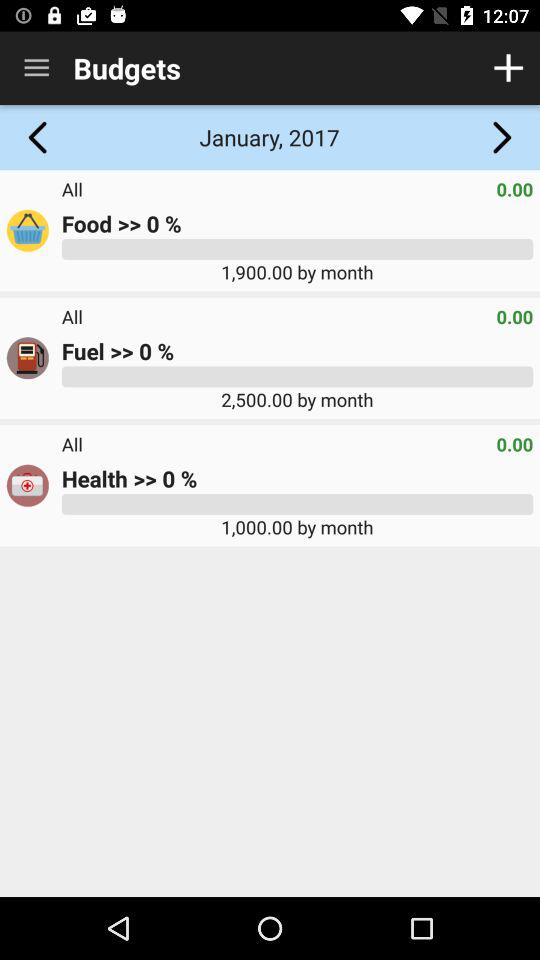Which month and year are displayed in "Budgets"? The displayed month and year are January and 2017, respectively. 